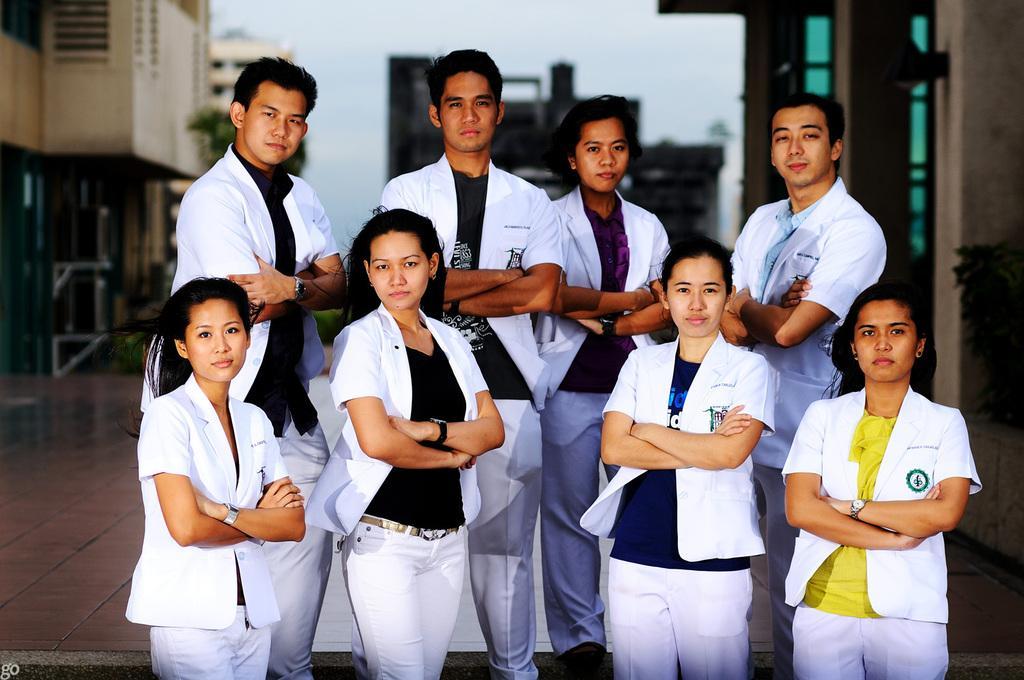How would you summarize this image in a sentence or two? In this picture I can see few people standing and they wore white color coats and I can see buildings and a tree and I can see a cloudy sky. 